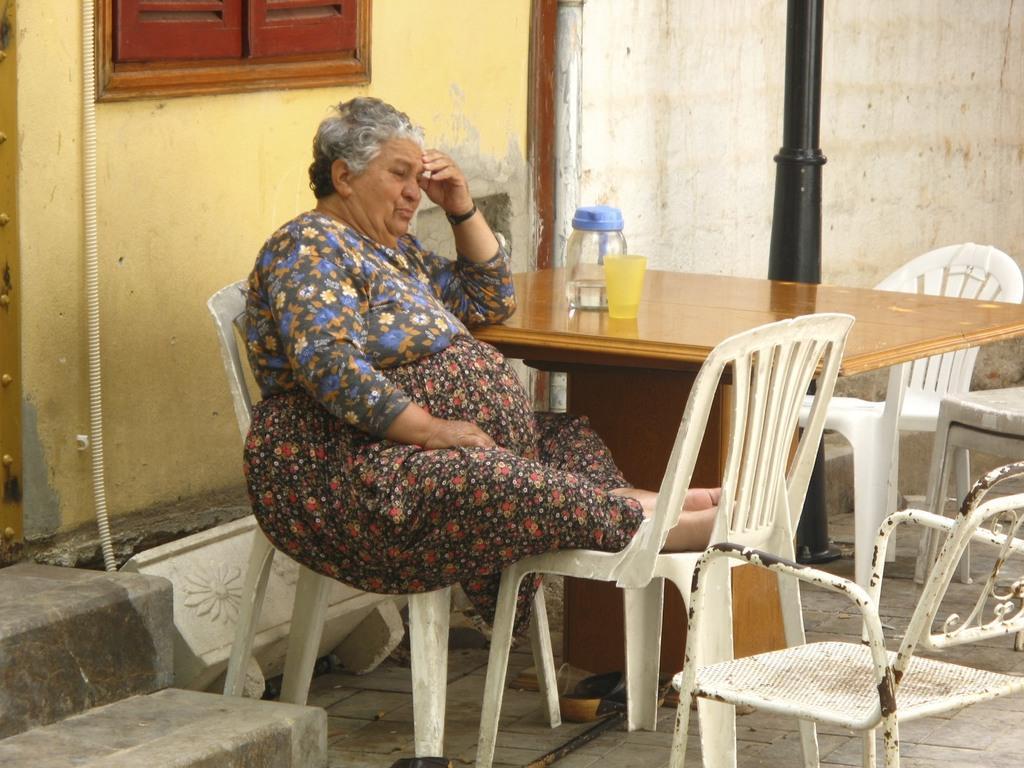How would you summarize this image in a sentence or two? As we can see in the image there is a woman who sitting on both the chairs. She is resting her legs on another chair and beside her there is a table on which there is a jug of water is kept and beside it there a yellow colour glass and at the back of the table there is a wall and in front of it there is a black colour pole and behind the women there is yellow colour wall and above it there red colour window and beside it there are stairs. 